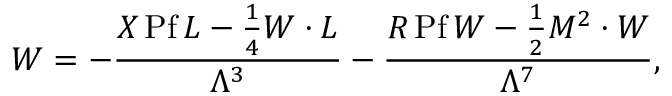Convert formula to latex. <formula><loc_0><loc_0><loc_500><loc_500>W = - { \frac { X { \, P f \, } L - \frac { 1 } { 4 } W \cdot L } { \Lambda ^ { 3 } } } - { \frac { R { \, P f \, } W - \frac { 1 } { 2 } M ^ { 2 } \cdot W } { \Lambda ^ { 7 } } } ,</formula> 